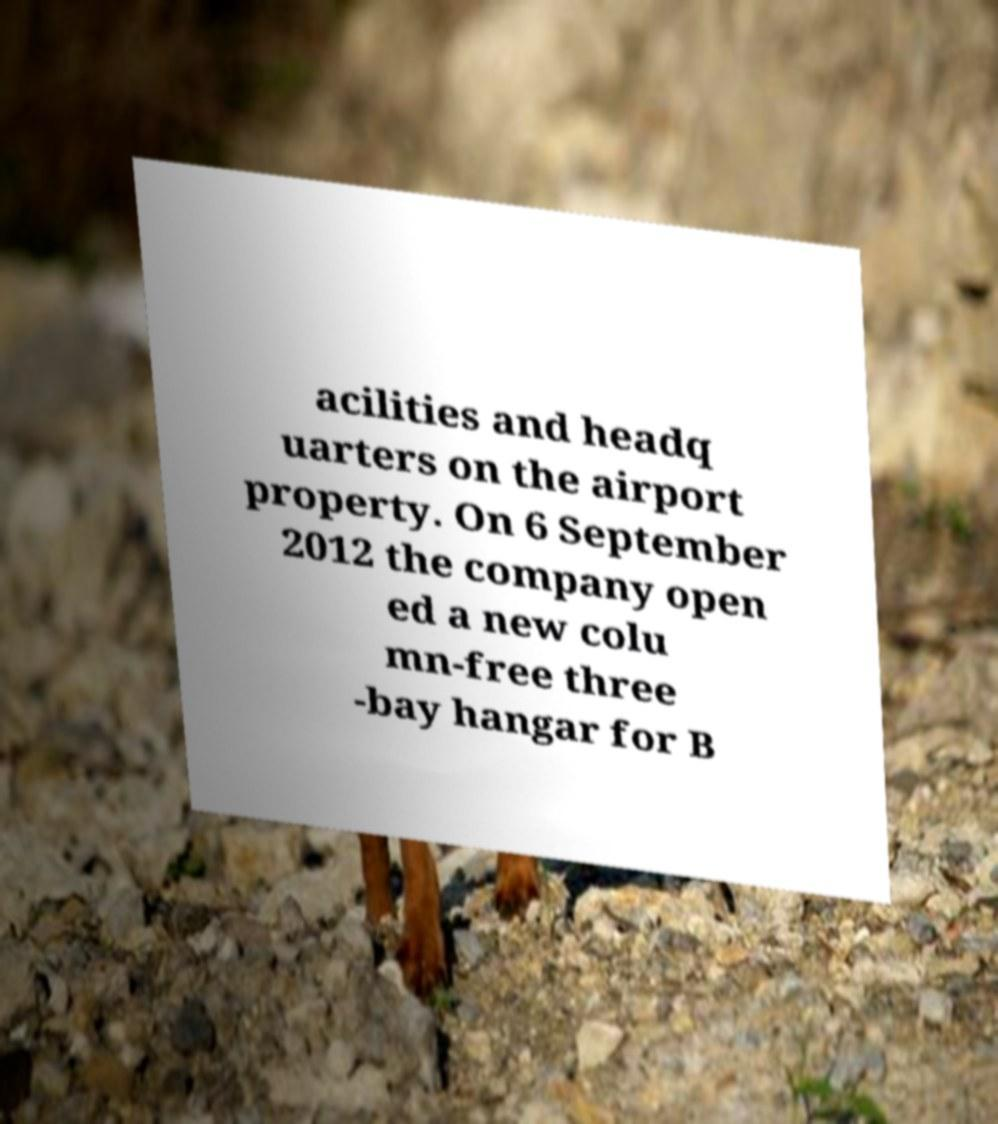Can you read and provide the text displayed in the image?This photo seems to have some interesting text. Can you extract and type it out for me? acilities and headq uarters on the airport property. On 6 September 2012 the company open ed a new colu mn-free three -bay hangar for B 